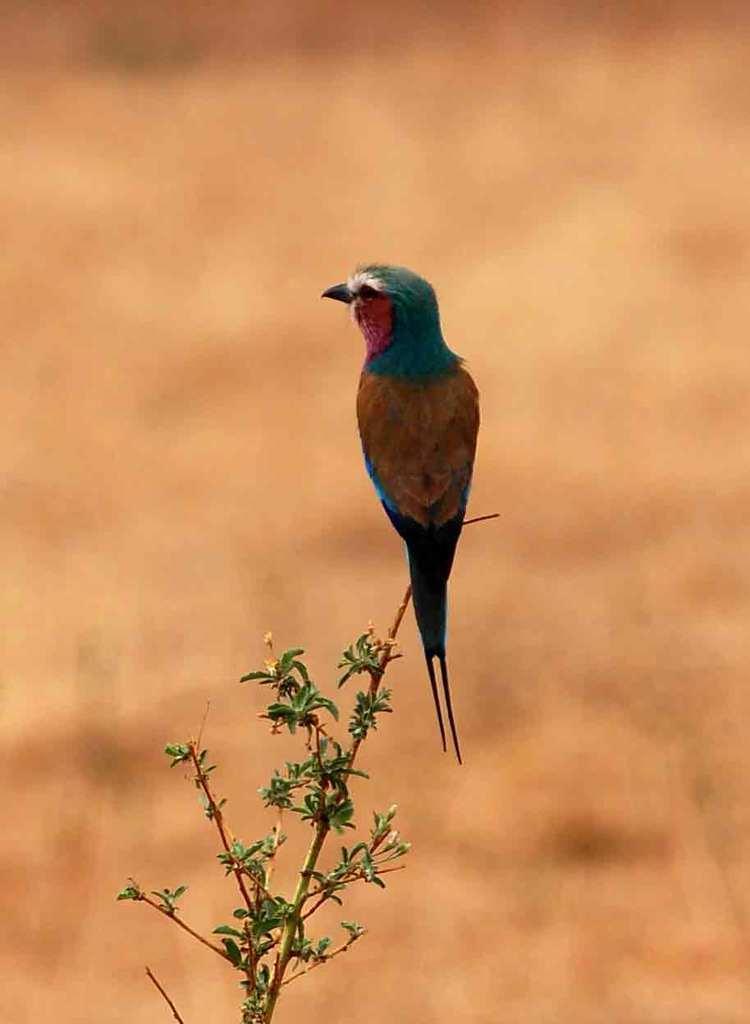In one or two sentences, can you explain what this image depicts? In the image we can see a bird, which is of white, light blue, pink, yellow and dark blue in color and it is sitting on a plant. 